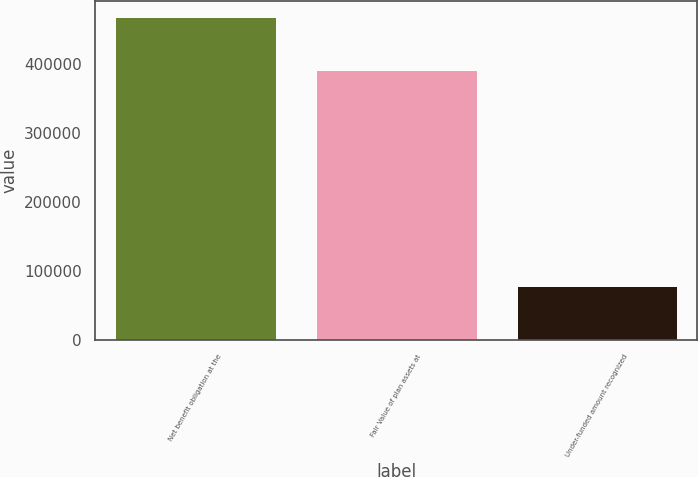Convert chart to OTSL. <chart><loc_0><loc_0><loc_500><loc_500><bar_chart><fcel>Net benefit obligation at the<fcel>Fair Value of plan assets at<fcel>Under-funded amount recognized<nl><fcel>468439<fcel>390777<fcel>77662<nl></chart> 